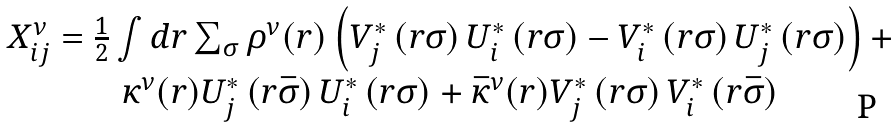Convert formula to latex. <formula><loc_0><loc_0><loc_500><loc_500>\begin{array} { c } X ^ { \nu } _ { i j } = \frac { 1 } { 2 } \int d { r } \sum _ { \sigma } \rho ^ { \nu } ( { r } ) \left ( V ^ { * } _ { j } \left ( { r } \sigma \right ) U ^ { * } _ { i } \left ( { r } \sigma \right ) - V ^ { * } _ { i } \left ( { r } \sigma \right ) U ^ { * } _ { j } \left ( { r } \sigma \right ) \right ) + \\ \kappa ^ { \nu } ( { r } ) U ^ { * } _ { j } \left ( { r } \bar { \sigma } \right ) U ^ { * } _ { i } \left ( { r } \sigma \right ) + \bar { \kappa } ^ { \nu } ( { r } ) V ^ { * } _ { j } \left ( { r } \sigma \right ) V ^ { * } _ { i } \left ( { r } \bar { \sigma } \right ) \\ \end{array}</formula> 